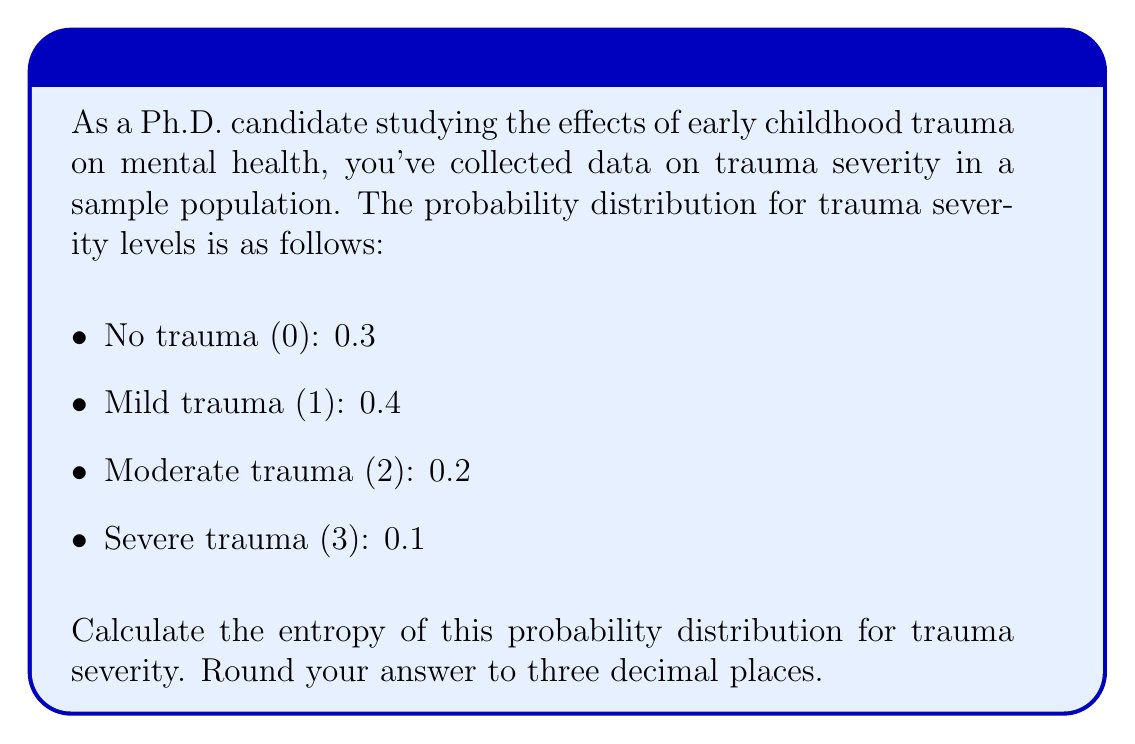Give your solution to this math problem. To calculate the entropy of a probability distribution, we use the formula:

$$H = -\sum_{i=1}^{n} p_i \log_2(p_i)$$

Where $H$ is the entropy, $p_i$ is the probability of each outcome, and $n$ is the number of possible outcomes.

Let's calculate each term:

1. For no trauma (0): 
   $-0.3 \log_2(0.3) = 0.3 \times 1.737 = 0.5211$

2. For mild trauma (1):
   $-0.4 \log_2(0.4) = 0.4 \times 1.322 = 0.5288$

3. For moderate trauma (2):
   $-0.2 \log_2(0.2) = 0.2 \times 2.322 = 0.4644$

4. For severe trauma (3):
   $-0.1 \log_2(0.1) = 0.1 \times 3.322 = 0.3322$

Now, sum all these terms:

$$H = 0.5211 + 0.5288 + 0.4644 + 0.3322 = 1.8465$$

Rounding to three decimal places, we get 1.847 bits.
Answer: 1.847 bits 